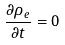<formula> <loc_0><loc_0><loc_500><loc_500>\frac { \partial \rho _ { e } } { \partial t } = 0</formula> 